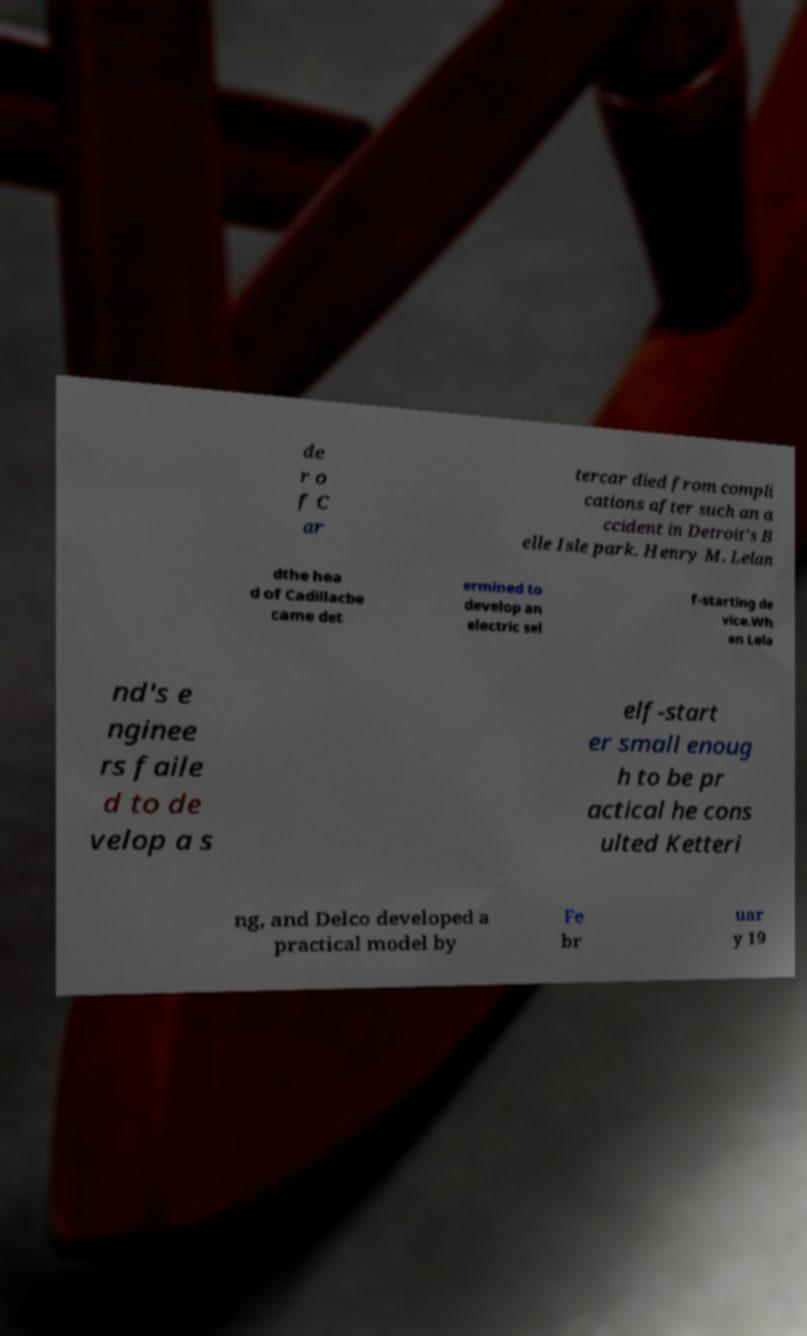Could you assist in decoding the text presented in this image and type it out clearly? de r o f C ar tercar died from compli cations after such an a ccident in Detroit's B elle Isle park. Henry M. Lelan dthe hea d of Cadillacbe came det ermined to develop an electric sel f-starting de vice.Wh en Lela nd's e nginee rs faile d to de velop a s elf-start er small enoug h to be pr actical he cons ulted Ketteri ng, and Delco developed a practical model by Fe br uar y 19 